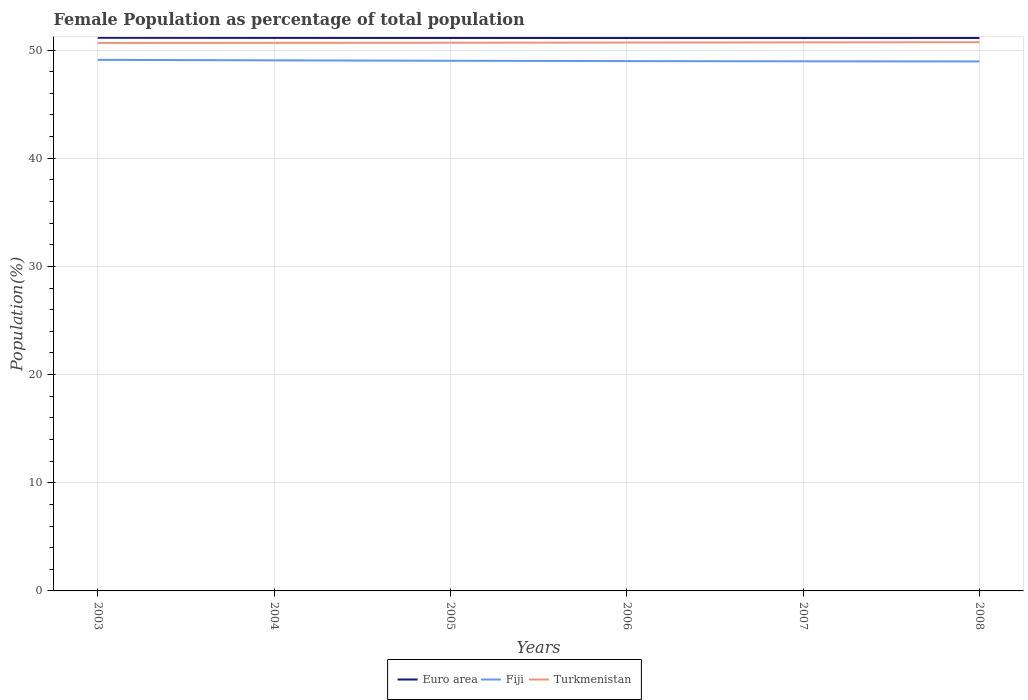How many different coloured lines are there?
Offer a very short reply. 3. Does the line corresponding to Euro area intersect with the line corresponding to Fiji?
Your response must be concise. No. Across all years, what is the maximum female population in in Euro area?
Your answer should be very brief. 51.11. In which year was the female population in in Euro area maximum?
Provide a short and direct response. 2007. What is the total female population in in Turkmenistan in the graph?
Make the answer very short. -0.03. What is the difference between the highest and the second highest female population in in Euro area?
Provide a short and direct response. 0.02. How many lines are there?
Provide a short and direct response. 3. How many years are there in the graph?
Give a very brief answer. 6. What is the difference between two consecutive major ticks on the Y-axis?
Your answer should be very brief. 10. Are the values on the major ticks of Y-axis written in scientific E-notation?
Make the answer very short. No. How are the legend labels stacked?
Provide a short and direct response. Horizontal. What is the title of the graph?
Make the answer very short. Female Population as percentage of total population. Does "St. Lucia" appear as one of the legend labels in the graph?
Offer a terse response. No. What is the label or title of the Y-axis?
Give a very brief answer. Population(%). What is the Population(%) in Euro area in 2003?
Keep it short and to the point. 51.14. What is the Population(%) in Fiji in 2003?
Your answer should be compact. 49.1. What is the Population(%) of Turkmenistan in 2003?
Give a very brief answer. 50.65. What is the Population(%) of Euro area in 2004?
Ensure brevity in your answer.  51.12. What is the Population(%) of Fiji in 2004?
Your answer should be compact. 49.05. What is the Population(%) of Turkmenistan in 2004?
Ensure brevity in your answer.  50.66. What is the Population(%) of Euro area in 2005?
Provide a short and direct response. 51.12. What is the Population(%) in Fiji in 2005?
Keep it short and to the point. 49.01. What is the Population(%) in Turkmenistan in 2005?
Offer a very short reply. 50.68. What is the Population(%) of Euro area in 2006?
Your response must be concise. 51.11. What is the Population(%) of Fiji in 2006?
Offer a very short reply. 48.98. What is the Population(%) of Turkmenistan in 2006?
Your response must be concise. 50.69. What is the Population(%) in Euro area in 2007?
Provide a short and direct response. 51.11. What is the Population(%) of Fiji in 2007?
Make the answer very short. 48.96. What is the Population(%) in Turkmenistan in 2007?
Your answer should be very brief. 50.71. What is the Population(%) of Euro area in 2008?
Make the answer very short. 51.12. What is the Population(%) of Fiji in 2008?
Offer a terse response. 48.95. What is the Population(%) in Turkmenistan in 2008?
Offer a very short reply. 50.72. Across all years, what is the maximum Population(%) of Euro area?
Your answer should be very brief. 51.14. Across all years, what is the maximum Population(%) of Fiji?
Your answer should be compact. 49.1. Across all years, what is the maximum Population(%) in Turkmenistan?
Keep it short and to the point. 50.72. Across all years, what is the minimum Population(%) in Euro area?
Your answer should be compact. 51.11. Across all years, what is the minimum Population(%) of Fiji?
Your answer should be compact. 48.95. Across all years, what is the minimum Population(%) of Turkmenistan?
Make the answer very short. 50.65. What is the total Population(%) in Euro area in the graph?
Offer a terse response. 306.72. What is the total Population(%) in Fiji in the graph?
Provide a short and direct response. 294.04. What is the total Population(%) in Turkmenistan in the graph?
Your answer should be compact. 304.12. What is the difference between the Population(%) of Euro area in 2003 and that in 2004?
Provide a succinct answer. 0.01. What is the difference between the Population(%) in Fiji in 2003 and that in 2004?
Keep it short and to the point. 0.05. What is the difference between the Population(%) of Turkmenistan in 2003 and that in 2004?
Provide a succinct answer. -0.01. What is the difference between the Population(%) of Euro area in 2003 and that in 2005?
Offer a very short reply. 0.02. What is the difference between the Population(%) of Fiji in 2003 and that in 2005?
Keep it short and to the point. 0.09. What is the difference between the Population(%) in Turkmenistan in 2003 and that in 2005?
Keep it short and to the point. -0.02. What is the difference between the Population(%) of Euro area in 2003 and that in 2006?
Your answer should be very brief. 0.02. What is the difference between the Population(%) of Fiji in 2003 and that in 2006?
Make the answer very short. 0.12. What is the difference between the Population(%) in Turkmenistan in 2003 and that in 2006?
Give a very brief answer. -0.04. What is the difference between the Population(%) of Euro area in 2003 and that in 2007?
Ensure brevity in your answer.  0.02. What is the difference between the Population(%) of Fiji in 2003 and that in 2007?
Ensure brevity in your answer.  0.14. What is the difference between the Population(%) of Turkmenistan in 2003 and that in 2007?
Your response must be concise. -0.05. What is the difference between the Population(%) in Euro area in 2003 and that in 2008?
Ensure brevity in your answer.  0.02. What is the difference between the Population(%) in Fiji in 2003 and that in 2008?
Offer a very short reply. 0.15. What is the difference between the Population(%) in Turkmenistan in 2003 and that in 2008?
Give a very brief answer. -0.07. What is the difference between the Population(%) of Euro area in 2004 and that in 2005?
Give a very brief answer. 0.01. What is the difference between the Population(%) in Fiji in 2004 and that in 2005?
Offer a very short reply. 0.04. What is the difference between the Population(%) of Turkmenistan in 2004 and that in 2005?
Your answer should be very brief. -0.01. What is the difference between the Population(%) of Euro area in 2004 and that in 2006?
Offer a terse response. 0.01. What is the difference between the Population(%) of Fiji in 2004 and that in 2006?
Provide a short and direct response. 0.07. What is the difference between the Population(%) of Turkmenistan in 2004 and that in 2006?
Keep it short and to the point. -0.03. What is the difference between the Population(%) of Euro area in 2004 and that in 2007?
Provide a succinct answer. 0.01. What is the difference between the Population(%) in Fiji in 2004 and that in 2007?
Your response must be concise. 0.09. What is the difference between the Population(%) of Turkmenistan in 2004 and that in 2007?
Make the answer very short. -0.04. What is the difference between the Population(%) in Euro area in 2004 and that in 2008?
Your answer should be compact. 0.01. What is the difference between the Population(%) of Fiji in 2004 and that in 2008?
Your answer should be very brief. 0.1. What is the difference between the Population(%) of Turkmenistan in 2004 and that in 2008?
Your answer should be very brief. -0.06. What is the difference between the Population(%) of Euro area in 2005 and that in 2006?
Your answer should be very brief. 0. What is the difference between the Population(%) of Fiji in 2005 and that in 2006?
Make the answer very short. 0.03. What is the difference between the Population(%) of Turkmenistan in 2005 and that in 2006?
Give a very brief answer. -0.01. What is the difference between the Population(%) in Euro area in 2005 and that in 2007?
Keep it short and to the point. 0. What is the difference between the Population(%) of Fiji in 2005 and that in 2007?
Keep it short and to the point. 0.05. What is the difference between the Population(%) in Turkmenistan in 2005 and that in 2007?
Your answer should be very brief. -0.03. What is the difference between the Population(%) of Fiji in 2005 and that in 2008?
Provide a short and direct response. 0.06. What is the difference between the Population(%) of Turkmenistan in 2005 and that in 2008?
Make the answer very short. -0.05. What is the difference between the Population(%) of Euro area in 2006 and that in 2007?
Your answer should be compact. 0. What is the difference between the Population(%) in Fiji in 2006 and that in 2007?
Offer a terse response. 0.02. What is the difference between the Population(%) of Turkmenistan in 2006 and that in 2007?
Provide a succinct answer. -0.02. What is the difference between the Population(%) in Euro area in 2006 and that in 2008?
Offer a very short reply. -0. What is the difference between the Population(%) of Fiji in 2006 and that in 2008?
Your response must be concise. 0.03. What is the difference between the Population(%) in Turkmenistan in 2006 and that in 2008?
Offer a very short reply. -0.03. What is the difference between the Population(%) in Euro area in 2007 and that in 2008?
Your response must be concise. -0. What is the difference between the Population(%) in Fiji in 2007 and that in 2008?
Keep it short and to the point. 0.01. What is the difference between the Population(%) of Turkmenistan in 2007 and that in 2008?
Your response must be concise. -0.02. What is the difference between the Population(%) in Euro area in 2003 and the Population(%) in Fiji in 2004?
Make the answer very short. 2.09. What is the difference between the Population(%) in Euro area in 2003 and the Population(%) in Turkmenistan in 2004?
Give a very brief answer. 0.47. What is the difference between the Population(%) of Fiji in 2003 and the Population(%) of Turkmenistan in 2004?
Provide a succinct answer. -1.57. What is the difference between the Population(%) in Euro area in 2003 and the Population(%) in Fiji in 2005?
Keep it short and to the point. 2.13. What is the difference between the Population(%) in Euro area in 2003 and the Population(%) in Turkmenistan in 2005?
Your answer should be very brief. 0.46. What is the difference between the Population(%) in Fiji in 2003 and the Population(%) in Turkmenistan in 2005?
Provide a short and direct response. -1.58. What is the difference between the Population(%) of Euro area in 2003 and the Population(%) of Fiji in 2006?
Offer a terse response. 2.16. What is the difference between the Population(%) in Euro area in 2003 and the Population(%) in Turkmenistan in 2006?
Your answer should be very brief. 0.45. What is the difference between the Population(%) of Fiji in 2003 and the Population(%) of Turkmenistan in 2006?
Offer a very short reply. -1.6. What is the difference between the Population(%) of Euro area in 2003 and the Population(%) of Fiji in 2007?
Provide a short and direct response. 2.18. What is the difference between the Population(%) of Euro area in 2003 and the Population(%) of Turkmenistan in 2007?
Your answer should be very brief. 0.43. What is the difference between the Population(%) in Fiji in 2003 and the Population(%) in Turkmenistan in 2007?
Make the answer very short. -1.61. What is the difference between the Population(%) of Euro area in 2003 and the Population(%) of Fiji in 2008?
Ensure brevity in your answer.  2.19. What is the difference between the Population(%) in Euro area in 2003 and the Population(%) in Turkmenistan in 2008?
Make the answer very short. 0.41. What is the difference between the Population(%) in Fiji in 2003 and the Population(%) in Turkmenistan in 2008?
Give a very brief answer. -1.63. What is the difference between the Population(%) in Euro area in 2004 and the Population(%) in Fiji in 2005?
Your response must be concise. 2.12. What is the difference between the Population(%) in Euro area in 2004 and the Population(%) in Turkmenistan in 2005?
Provide a succinct answer. 0.45. What is the difference between the Population(%) of Fiji in 2004 and the Population(%) of Turkmenistan in 2005?
Provide a short and direct response. -1.63. What is the difference between the Population(%) in Euro area in 2004 and the Population(%) in Fiji in 2006?
Make the answer very short. 2.14. What is the difference between the Population(%) of Euro area in 2004 and the Population(%) of Turkmenistan in 2006?
Provide a succinct answer. 0.43. What is the difference between the Population(%) of Fiji in 2004 and the Population(%) of Turkmenistan in 2006?
Your response must be concise. -1.64. What is the difference between the Population(%) in Euro area in 2004 and the Population(%) in Fiji in 2007?
Offer a very short reply. 2.17. What is the difference between the Population(%) of Euro area in 2004 and the Population(%) of Turkmenistan in 2007?
Your answer should be very brief. 0.42. What is the difference between the Population(%) of Fiji in 2004 and the Population(%) of Turkmenistan in 2007?
Offer a very short reply. -1.66. What is the difference between the Population(%) of Euro area in 2004 and the Population(%) of Fiji in 2008?
Keep it short and to the point. 2.18. What is the difference between the Population(%) of Euro area in 2004 and the Population(%) of Turkmenistan in 2008?
Offer a very short reply. 0.4. What is the difference between the Population(%) of Fiji in 2004 and the Population(%) of Turkmenistan in 2008?
Offer a very short reply. -1.68. What is the difference between the Population(%) in Euro area in 2005 and the Population(%) in Fiji in 2006?
Provide a short and direct response. 2.14. What is the difference between the Population(%) in Euro area in 2005 and the Population(%) in Turkmenistan in 2006?
Provide a succinct answer. 0.43. What is the difference between the Population(%) of Fiji in 2005 and the Population(%) of Turkmenistan in 2006?
Make the answer very short. -1.68. What is the difference between the Population(%) of Euro area in 2005 and the Population(%) of Fiji in 2007?
Offer a terse response. 2.16. What is the difference between the Population(%) of Euro area in 2005 and the Population(%) of Turkmenistan in 2007?
Provide a succinct answer. 0.41. What is the difference between the Population(%) in Fiji in 2005 and the Population(%) in Turkmenistan in 2007?
Your answer should be very brief. -1.7. What is the difference between the Population(%) of Euro area in 2005 and the Population(%) of Fiji in 2008?
Give a very brief answer. 2.17. What is the difference between the Population(%) in Euro area in 2005 and the Population(%) in Turkmenistan in 2008?
Your response must be concise. 0.39. What is the difference between the Population(%) of Fiji in 2005 and the Population(%) of Turkmenistan in 2008?
Ensure brevity in your answer.  -1.71. What is the difference between the Population(%) of Euro area in 2006 and the Population(%) of Fiji in 2007?
Your response must be concise. 2.15. What is the difference between the Population(%) in Euro area in 2006 and the Population(%) in Turkmenistan in 2007?
Offer a very short reply. 0.41. What is the difference between the Population(%) in Fiji in 2006 and the Population(%) in Turkmenistan in 2007?
Give a very brief answer. -1.73. What is the difference between the Population(%) of Euro area in 2006 and the Population(%) of Fiji in 2008?
Keep it short and to the point. 2.17. What is the difference between the Population(%) of Euro area in 2006 and the Population(%) of Turkmenistan in 2008?
Offer a terse response. 0.39. What is the difference between the Population(%) in Fiji in 2006 and the Population(%) in Turkmenistan in 2008?
Provide a succinct answer. -1.74. What is the difference between the Population(%) of Euro area in 2007 and the Population(%) of Fiji in 2008?
Offer a terse response. 2.17. What is the difference between the Population(%) of Euro area in 2007 and the Population(%) of Turkmenistan in 2008?
Provide a short and direct response. 0.39. What is the difference between the Population(%) in Fiji in 2007 and the Population(%) in Turkmenistan in 2008?
Provide a succinct answer. -1.77. What is the average Population(%) of Euro area per year?
Give a very brief answer. 51.12. What is the average Population(%) in Fiji per year?
Your answer should be very brief. 49.01. What is the average Population(%) in Turkmenistan per year?
Your answer should be very brief. 50.69. In the year 2003, what is the difference between the Population(%) of Euro area and Population(%) of Fiji?
Your answer should be compact. 2.04. In the year 2003, what is the difference between the Population(%) of Euro area and Population(%) of Turkmenistan?
Make the answer very short. 0.48. In the year 2003, what is the difference between the Population(%) in Fiji and Population(%) in Turkmenistan?
Provide a succinct answer. -1.56. In the year 2004, what is the difference between the Population(%) in Euro area and Population(%) in Fiji?
Provide a succinct answer. 2.08. In the year 2004, what is the difference between the Population(%) in Euro area and Population(%) in Turkmenistan?
Ensure brevity in your answer.  0.46. In the year 2004, what is the difference between the Population(%) of Fiji and Population(%) of Turkmenistan?
Your answer should be very brief. -1.62. In the year 2005, what is the difference between the Population(%) of Euro area and Population(%) of Fiji?
Offer a very short reply. 2.11. In the year 2005, what is the difference between the Population(%) in Euro area and Population(%) in Turkmenistan?
Your answer should be compact. 0.44. In the year 2005, what is the difference between the Population(%) in Fiji and Population(%) in Turkmenistan?
Make the answer very short. -1.67. In the year 2006, what is the difference between the Population(%) in Euro area and Population(%) in Fiji?
Offer a terse response. 2.13. In the year 2006, what is the difference between the Population(%) in Euro area and Population(%) in Turkmenistan?
Offer a very short reply. 0.42. In the year 2006, what is the difference between the Population(%) of Fiji and Population(%) of Turkmenistan?
Provide a short and direct response. -1.71. In the year 2007, what is the difference between the Population(%) of Euro area and Population(%) of Fiji?
Ensure brevity in your answer.  2.15. In the year 2007, what is the difference between the Population(%) of Euro area and Population(%) of Turkmenistan?
Your answer should be compact. 0.41. In the year 2007, what is the difference between the Population(%) of Fiji and Population(%) of Turkmenistan?
Keep it short and to the point. -1.75. In the year 2008, what is the difference between the Population(%) of Euro area and Population(%) of Fiji?
Provide a succinct answer. 2.17. In the year 2008, what is the difference between the Population(%) in Euro area and Population(%) in Turkmenistan?
Your response must be concise. 0.39. In the year 2008, what is the difference between the Population(%) in Fiji and Population(%) in Turkmenistan?
Ensure brevity in your answer.  -1.78. What is the ratio of the Population(%) of Fiji in 2003 to that in 2004?
Keep it short and to the point. 1. What is the ratio of the Population(%) of Turkmenistan in 2003 to that in 2004?
Ensure brevity in your answer.  1. What is the ratio of the Population(%) of Euro area in 2003 to that in 2005?
Give a very brief answer. 1. What is the ratio of the Population(%) in Fiji in 2003 to that in 2006?
Keep it short and to the point. 1. What is the ratio of the Population(%) of Turkmenistan in 2003 to that in 2006?
Your answer should be compact. 1. What is the ratio of the Population(%) in Fiji in 2003 to that in 2007?
Offer a very short reply. 1. What is the ratio of the Population(%) of Euro area in 2003 to that in 2008?
Give a very brief answer. 1. What is the ratio of the Population(%) of Fiji in 2003 to that in 2008?
Offer a very short reply. 1. What is the ratio of the Population(%) in Turkmenistan in 2004 to that in 2005?
Provide a short and direct response. 1. What is the ratio of the Population(%) of Turkmenistan in 2004 to that in 2006?
Your answer should be very brief. 1. What is the ratio of the Population(%) in Fiji in 2004 to that in 2007?
Make the answer very short. 1. What is the ratio of the Population(%) in Fiji in 2005 to that in 2007?
Give a very brief answer. 1. What is the ratio of the Population(%) in Turkmenistan in 2005 to that in 2007?
Offer a very short reply. 1. What is the ratio of the Population(%) in Euro area in 2005 to that in 2008?
Provide a succinct answer. 1. What is the ratio of the Population(%) in Fiji in 2005 to that in 2008?
Your answer should be very brief. 1. What is the ratio of the Population(%) of Turkmenistan in 2006 to that in 2007?
Your answer should be very brief. 1. What is the ratio of the Population(%) in Fiji in 2006 to that in 2008?
Keep it short and to the point. 1. What is the ratio of the Population(%) of Turkmenistan in 2006 to that in 2008?
Offer a very short reply. 1. What is the ratio of the Population(%) of Euro area in 2007 to that in 2008?
Provide a succinct answer. 1. What is the ratio of the Population(%) of Fiji in 2007 to that in 2008?
Your answer should be very brief. 1. What is the difference between the highest and the second highest Population(%) of Euro area?
Provide a short and direct response. 0.01. What is the difference between the highest and the second highest Population(%) in Fiji?
Provide a succinct answer. 0.05. What is the difference between the highest and the second highest Population(%) of Turkmenistan?
Ensure brevity in your answer.  0.02. What is the difference between the highest and the lowest Population(%) of Euro area?
Your response must be concise. 0.02. What is the difference between the highest and the lowest Population(%) in Fiji?
Provide a short and direct response. 0.15. What is the difference between the highest and the lowest Population(%) of Turkmenistan?
Offer a terse response. 0.07. 